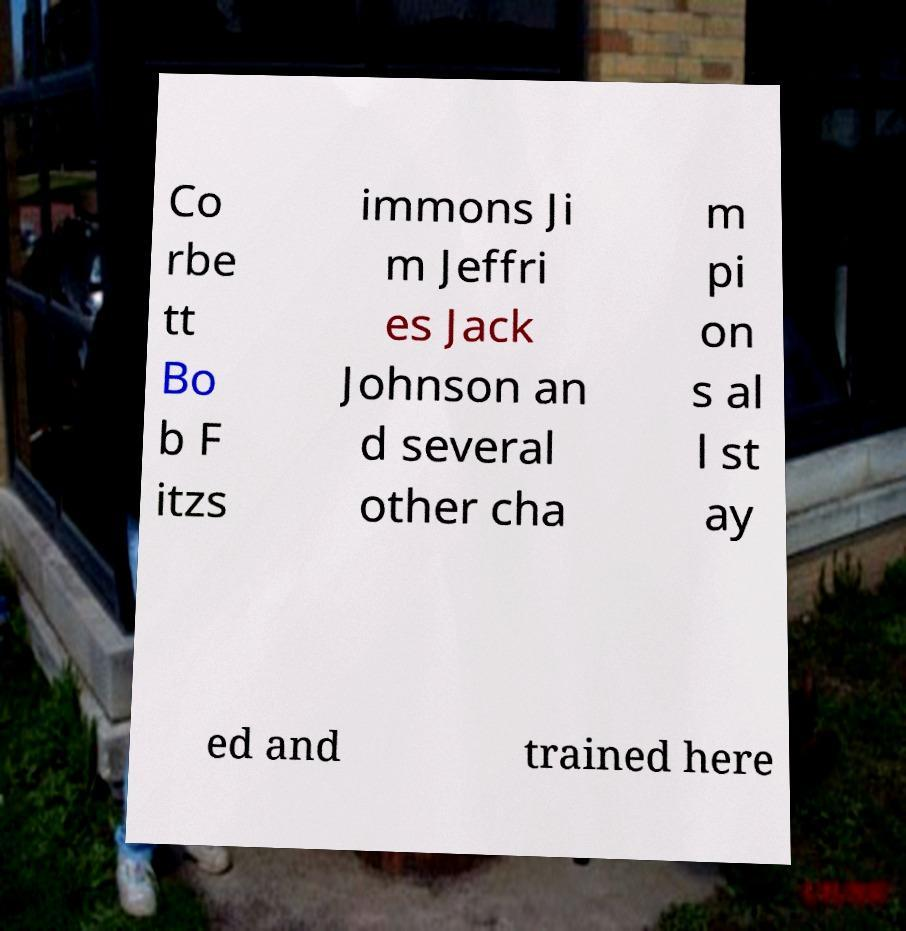Please identify and transcribe the text found in this image. Co rbe tt Bo b F itzs immons Ji m Jeffri es Jack Johnson an d several other cha m pi on s al l st ay ed and trained here 